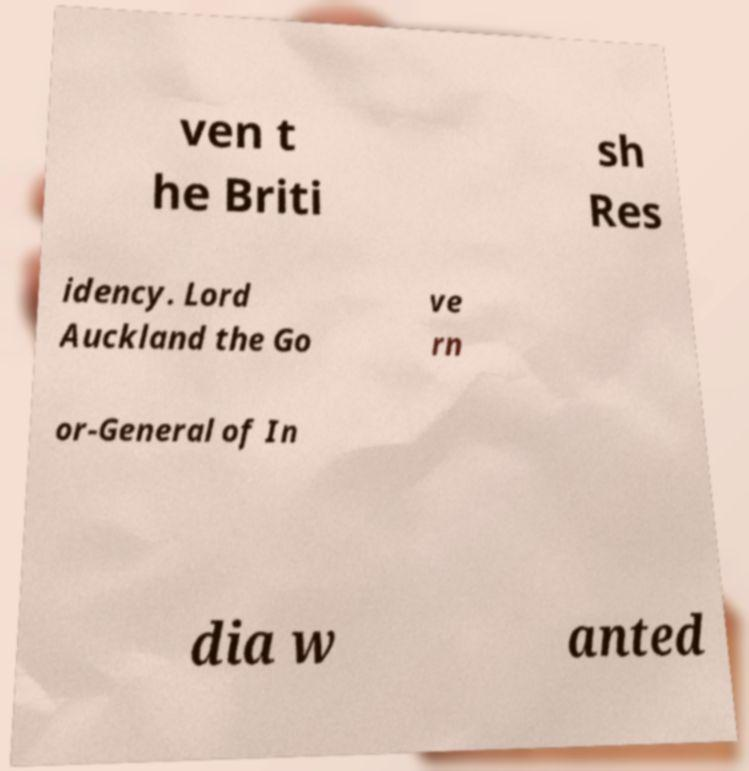Please read and relay the text visible in this image. What does it say? ven t he Briti sh Res idency. Lord Auckland the Go ve rn or-General of In dia w anted 